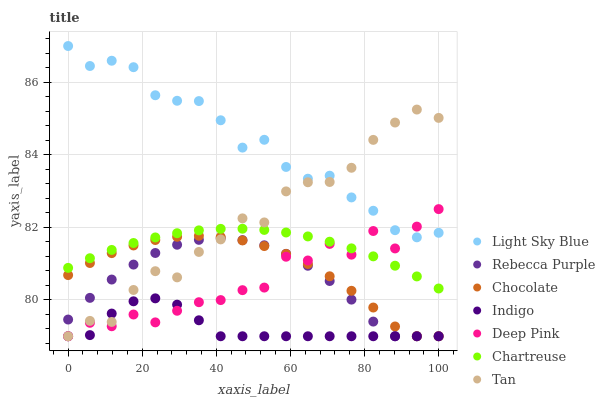Does Indigo have the minimum area under the curve?
Answer yes or no. Yes. Does Light Sky Blue have the maximum area under the curve?
Answer yes or no. Yes. Does Chocolate have the minimum area under the curve?
Answer yes or no. No. Does Chocolate have the maximum area under the curve?
Answer yes or no. No. Is Chartreuse the smoothest?
Answer yes or no. Yes. Is Deep Pink the roughest?
Answer yes or no. Yes. Is Indigo the smoothest?
Answer yes or no. No. Is Indigo the roughest?
Answer yes or no. No. Does Deep Pink have the lowest value?
Answer yes or no. Yes. Does Chartreuse have the lowest value?
Answer yes or no. No. Does Light Sky Blue have the highest value?
Answer yes or no. Yes. Does Chocolate have the highest value?
Answer yes or no. No. Is Indigo less than Chartreuse?
Answer yes or no. Yes. Is Light Sky Blue greater than Chocolate?
Answer yes or no. Yes. Does Deep Pink intersect Rebecca Purple?
Answer yes or no. Yes. Is Deep Pink less than Rebecca Purple?
Answer yes or no. No. Is Deep Pink greater than Rebecca Purple?
Answer yes or no. No. Does Indigo intersect Chartreuse?
Answer yes or no. No. 